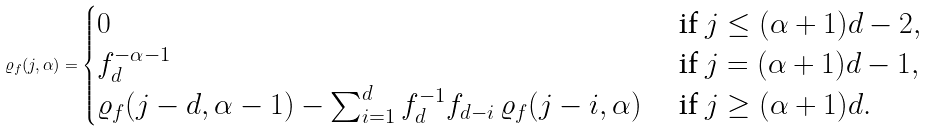Convert formula to latex. <formula><loc_0><loc_0><loc_500><loc_500>\varrho _ { f } ( j , \alpha ) = \begin{cases} 0 & \text { if } j \leq ( \alpha + 1 ) d - 2 , \\ f _ { d } ^ { - \alpha - 1 } & \text { if } j = ( \alpha + 1 ) d - 1 , \\ \varrho _ { f } ( j - d , \alpha - 1 ) - \sum _ { i = 1 } ^ { d } f _ { d } ^ { - 1 } { f _ { d - i } } \, \varrho _ { f } ( j - i , \alpha ) & \text { if } j \geq ( \alpha + 1 ) d . \end{cases}</formula> 